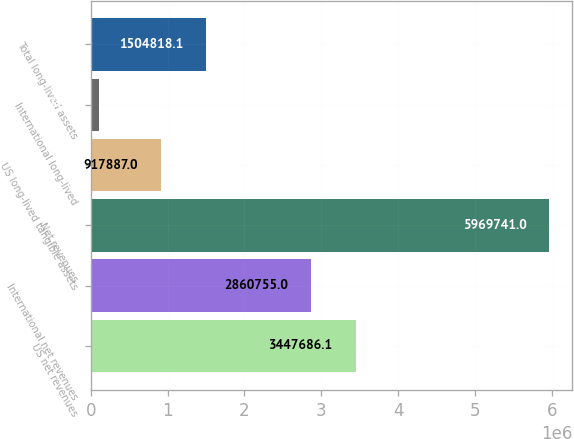Convert chart to OTSL. <chart><loc_0><loc_0><loc_500><loc_500><bar_chart><fcel>US net revenues<fcel>International net revenues<fcel>Net revenues<fcel>US long-lived tangible assets<fcel>International long-lived<fcel>Total long-lived assets<nl><fcel>3.44769e+06<fcel>2.86076e+06<fcel>5.96974e+06<fcel>917887<fcel>100430<fcel>1.50482e+06<nl></chart> 